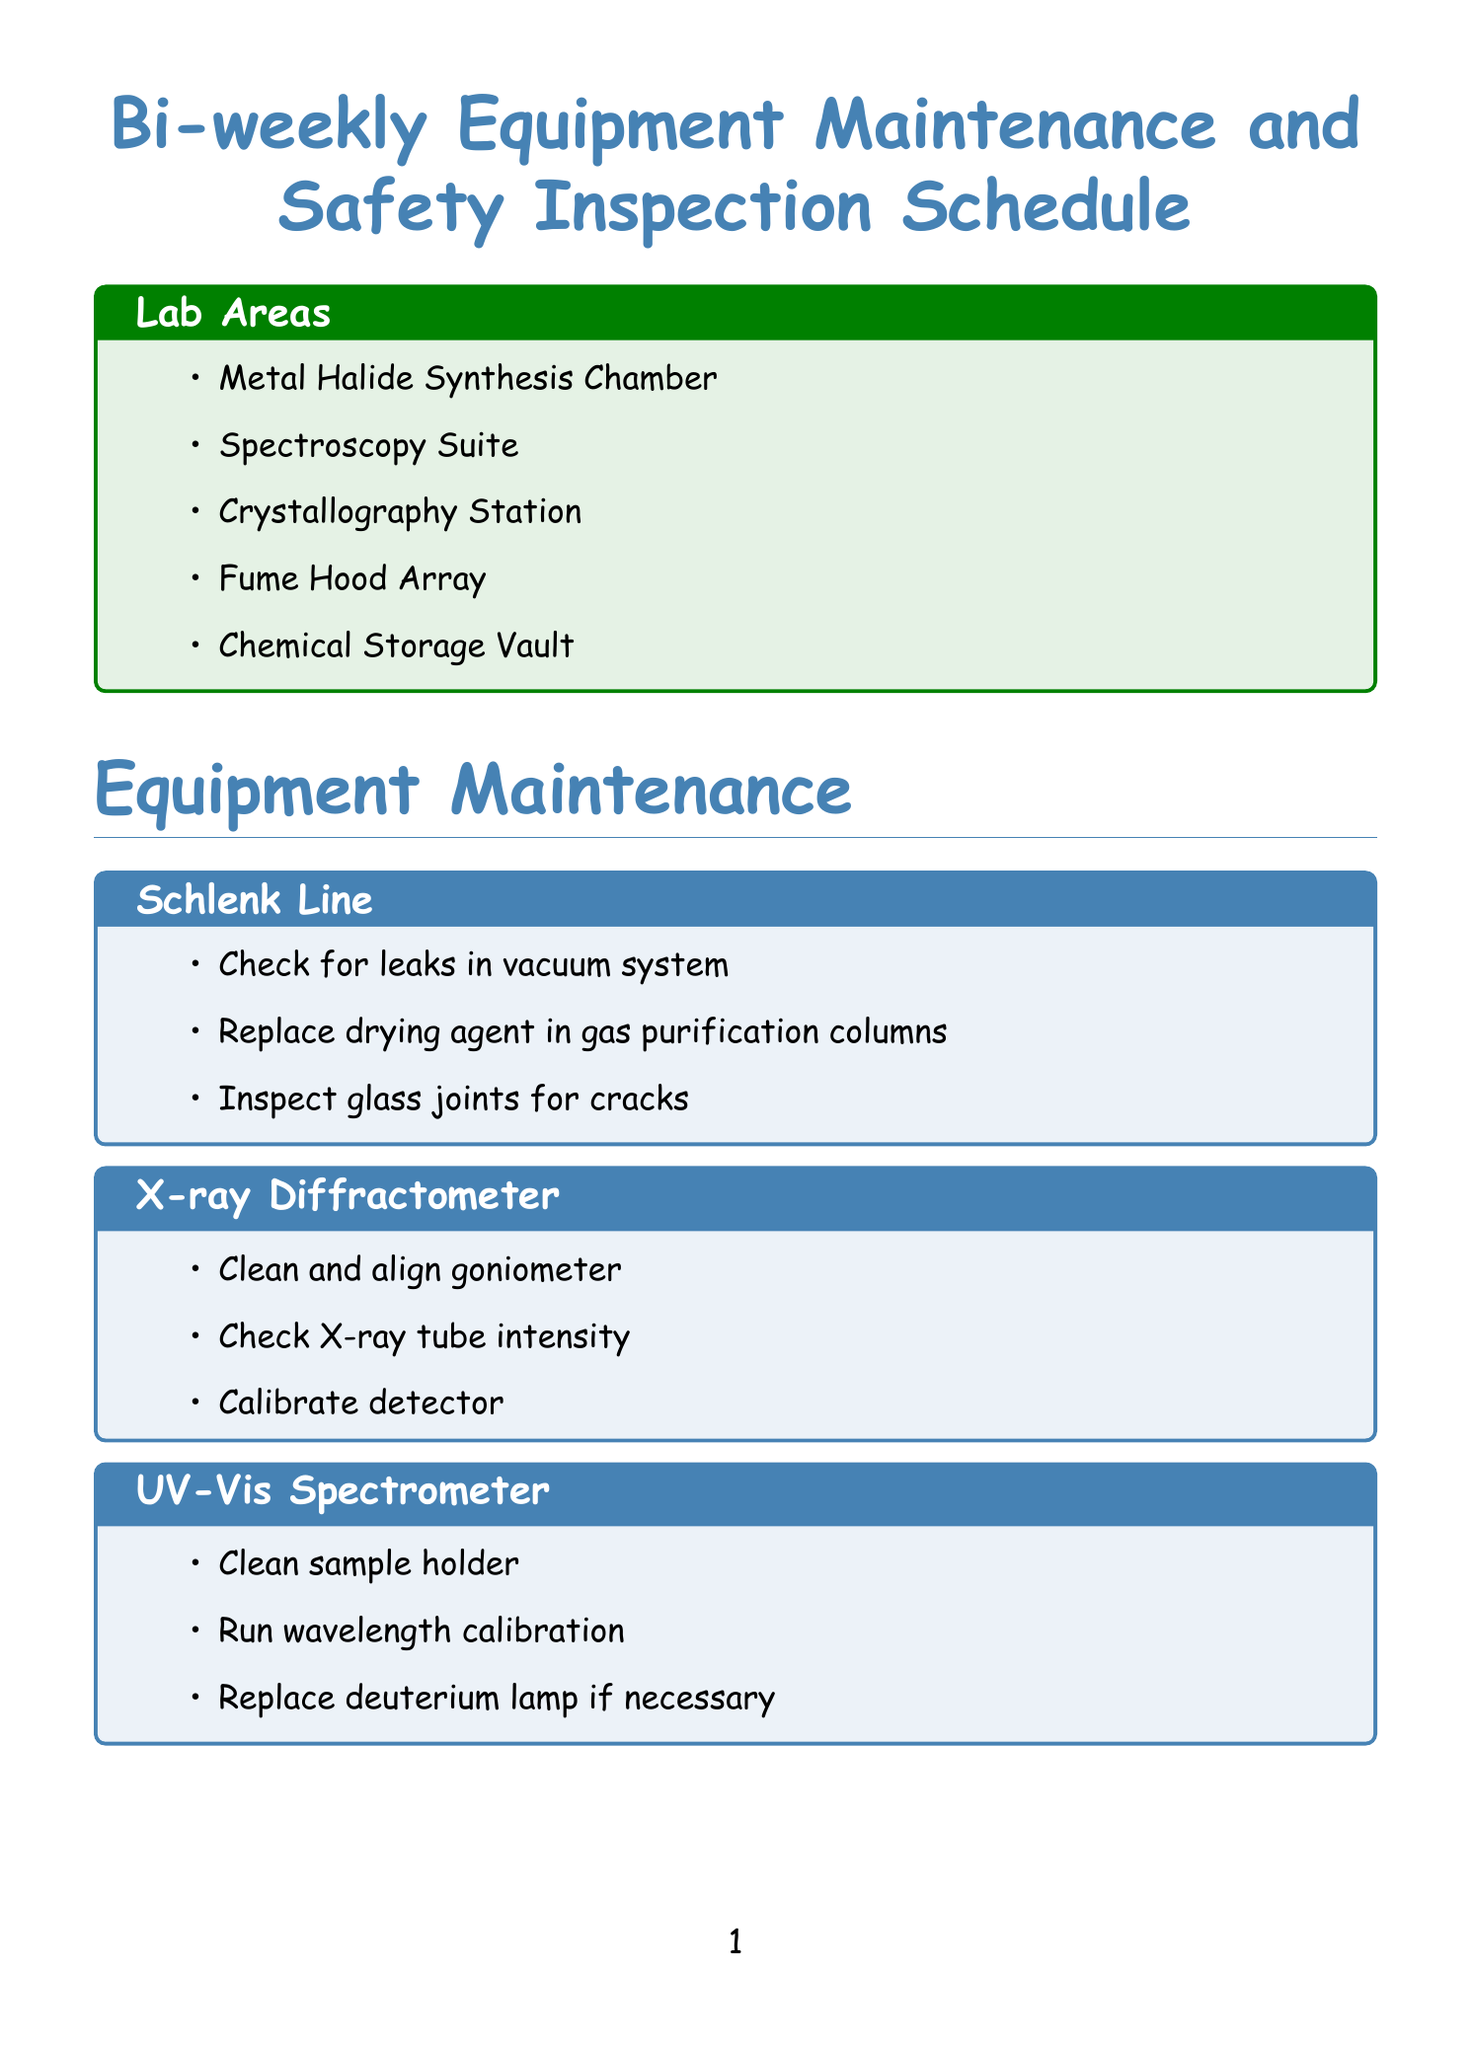What are the areas listed in the lab? The document lists the lab areas under "Lab Areas" section, which includes multiple specific locations.
Answer: Metal Halide Synthesis Chamber, Spectroscopy Suite, Crystallography Station, Fume Hood Array, Chemical Storage Vault How many maintenance tasks are listed for the Schlenk Line? By checking the maintenance tasks of the Schlenk Line in the document, we can see how many tasks are included.
Answer: 3 What is one task included in the safety inspection for the Chemical Storage? The document outlines several tasks for safety inspections, specifically under the Chemical Storage section.
Answer: Check for proper segregation of incompatible chemicals What is the first step in the Halide Dance Ritual? The Halide Dance Ritual includes a series of steps, the first of which is specified in the document.
Answer: Don the ceremonial lab coat adorned with periodic table elements How many emergency protocols are listed in the document? The document includes specific scenarios for emergency protocols, which can be counted for the total.
Answer: 2 